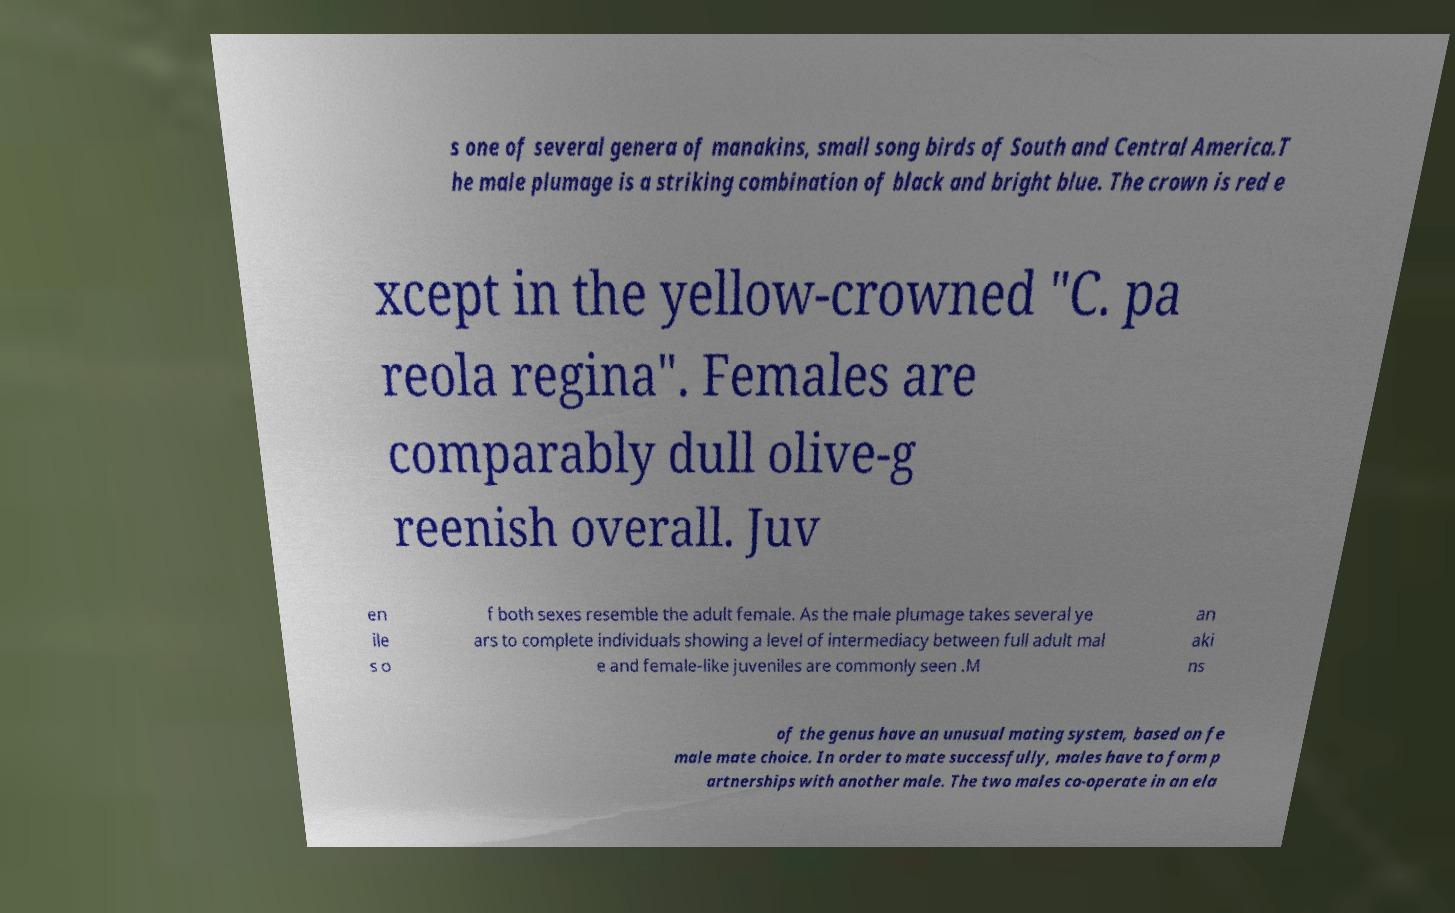I need the written content from this picture converted into text. Can you do that? s one of several genera of manakins, small song birds of South and Central America.T he male plumage is a striking combination of black and bright blue. The crown is red e xcept in the yellow-crowned "C. pa reola regina". Females are comparably dull olive-g reenish overall. Juv en ile s o f both sexes resemble the adult female. As the male plumage takes several ye ars to complete individuals showing a level of intermediacy between full adult mal e and female-like juveniles are commonly seen .M an aki ns of the genus have an unusual mating system, based on fe male mate choice. In order to mate successfully, males have to form p artnerships with another male. The two males co-operate in an ela 